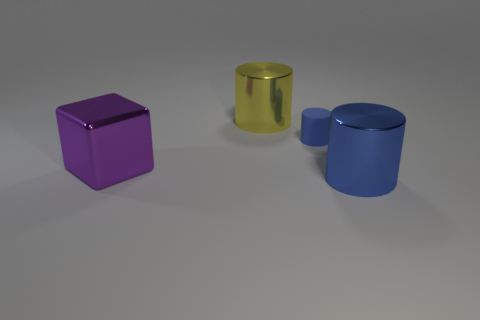There is a tiny rubber cylinder right of the purple object; is it the same color as the metal cylinder that is to the right of the tiny blue thing?
Ensure brevity in your answer.  Yes. Is there a large metallic object of the same color as the tiny rubber cylinder?
Make the answer very short. Yes. How many other objects are the same shape as the large purple thing?
Make the answer very short. 0. What shape is the blue object that is behind the big blue shiny thing?
Your answer should be very brief. Cylinder. There is a big yellow thing; is it the same shape as the large shiny object right of the rubber cylinder?
Keep it short and to the point. Yes. What is the size of the metal object that is both in front of the large yellow metal thing and right of the purple thing?
Offer a terse response. Large. The object that is both behind the large purple cube and on the left side of the small rubber cylinder is what color?
Ensure brevity in your answer.  Yellow. Is there any other thing that has the same material as the tiny cylinder?
Make the answer very short. No. Is the number of small things left of the yellow cylinder less than the number of large purple objects left of the large blue metal thing?
Your answer should be compact. Yes. Is there anything else that is the same color as the tiny cylinder?
Make the answer very short. Yes. 